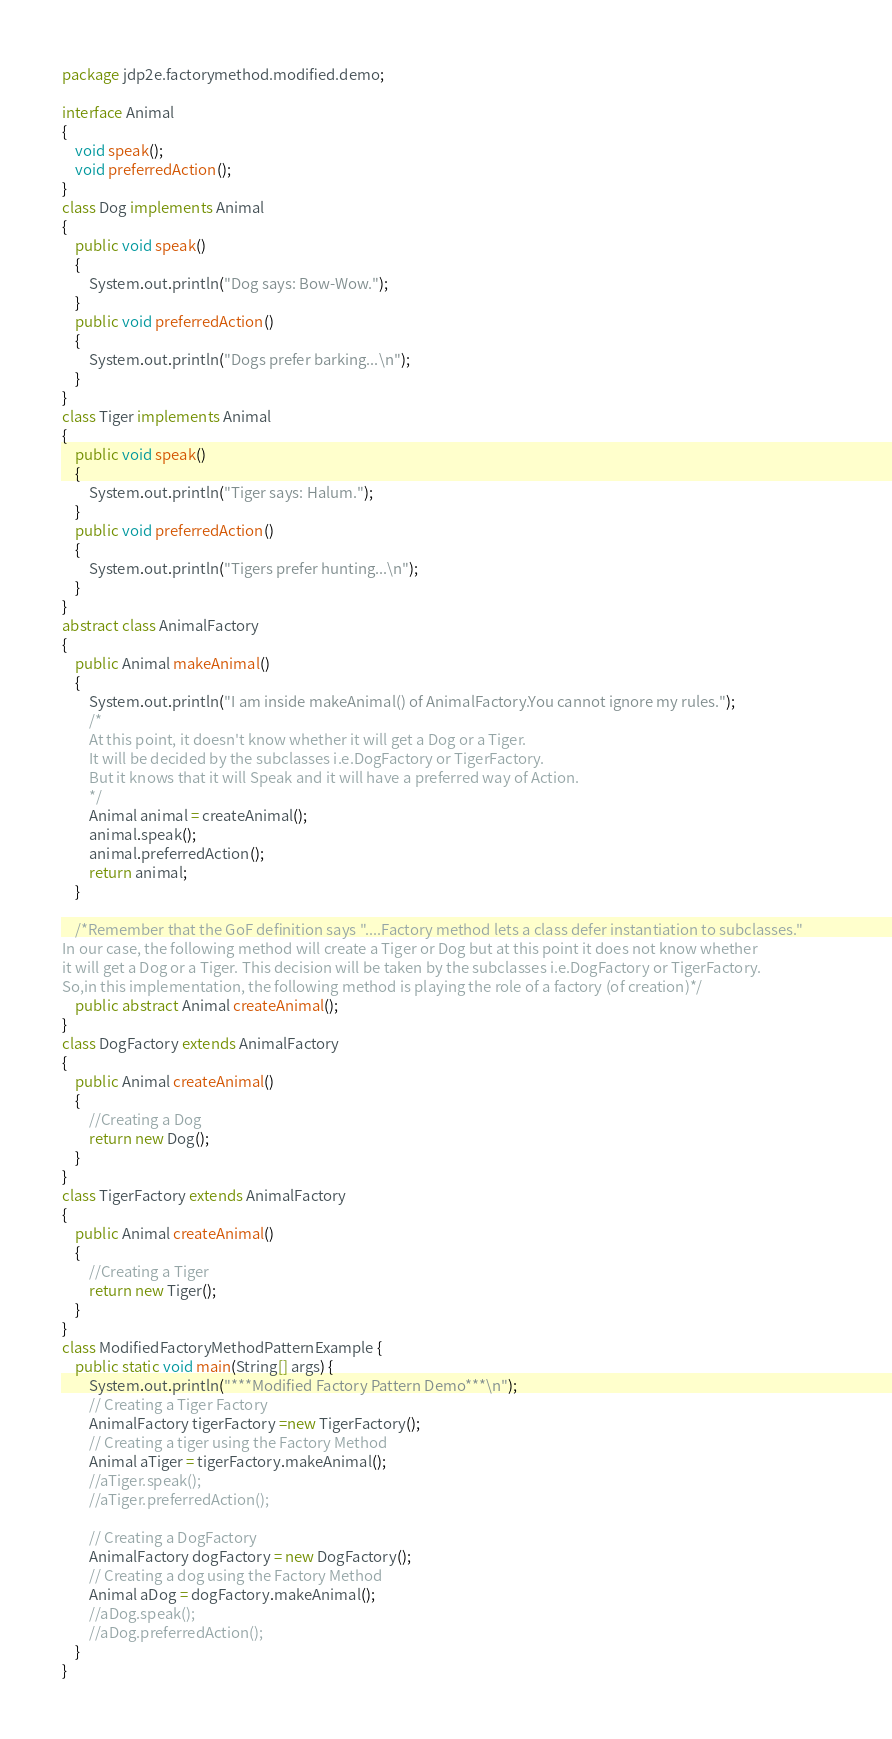Convert code to text. <code><loc_0><loc_0><loc_500><loc_500><_Java_>package jdp2e.factorymethod.modified.demo;

interface Animal
{
	void speak();
	void preferredAction();
}
class Dog implements Animal
{
	public void speak()
	{
		System.out.println("Dog says: Bow-Wow.");
	}
	public void preferredAction()
	{
		System.out.println("Dogs prefer barking...\n");
	}
}
class Tiger implements Animal
{
	public void speak()
	{
		System.out.println("Tiger says: Halum.");
	}
	public void preferredAction()
	{
		System.out.println("Tigers prefer hunting...\n");
	}
}
abstract class AnimalFactory
{
    public Animal makeAnimal()
    {
    	System.out.println("I am inside makeAnimal() of AnimalFactory.You cannot ignore my rules.");
        /*
        At this point, it doesn't know whether it will get a Dog or a Tiger.
        It will be decided by the subclasses i.e.DogFactory or TigerFactory.
        But it knows that it will Speak and it will have a preferred way of Action.
        */
        Animal animal = createAnimal();
        animal.speak();
        animal.preferredAction();
        return animal;
    }    

	/*Remember that the GoF definition says "....Factory method lets a class defer instantiation to subclasses."        
In our case, the following method will create a Tiger or Dog but at this point it does not know whether 
it will get a Dog or a Tiger. This decision will be taken by the subclasses i.e.DogFactory or TigerFactory.
So,in this implementation, the following method is playing the role of a factory (of creation)*/
	public abstract Animal createAnimal();        
}
class DogFactory extends AnimalFactory
{
	public Animal createAnimal()
	{
		//Creating a Dog
		return new Dog();               
	}
}
class TigerFactory extends AnimalFactory
{
	public Animal createAnimal()
	{
		//Creating a Tiger
		return new Tiger();
	}
}
class ModifiedFactoryMethodPatternExample {
	public static void main(String[] args) {
		System.out.println("***Modified Factory Pattern Demo***\n");
		// Creating a Tiger Factory 
		AnimalFactory tigerFactory =new TigerFactory();
		// Creating a tiger using the Factory Method
		Animal aTiger = tigerFactory.makeAnimal();
		//aTiger.speak();
		//aTiger.preferredAction();

		// Creating a DogFactory
		AnimalFactory dogFactory = new DogFactory();
		// Creating a dog using the Factory Method 
		Animal aDog = dogFactory.makeAnimal();
		//aDog.speak();
		//aDog.preferredAction();
	}
}


</code> 